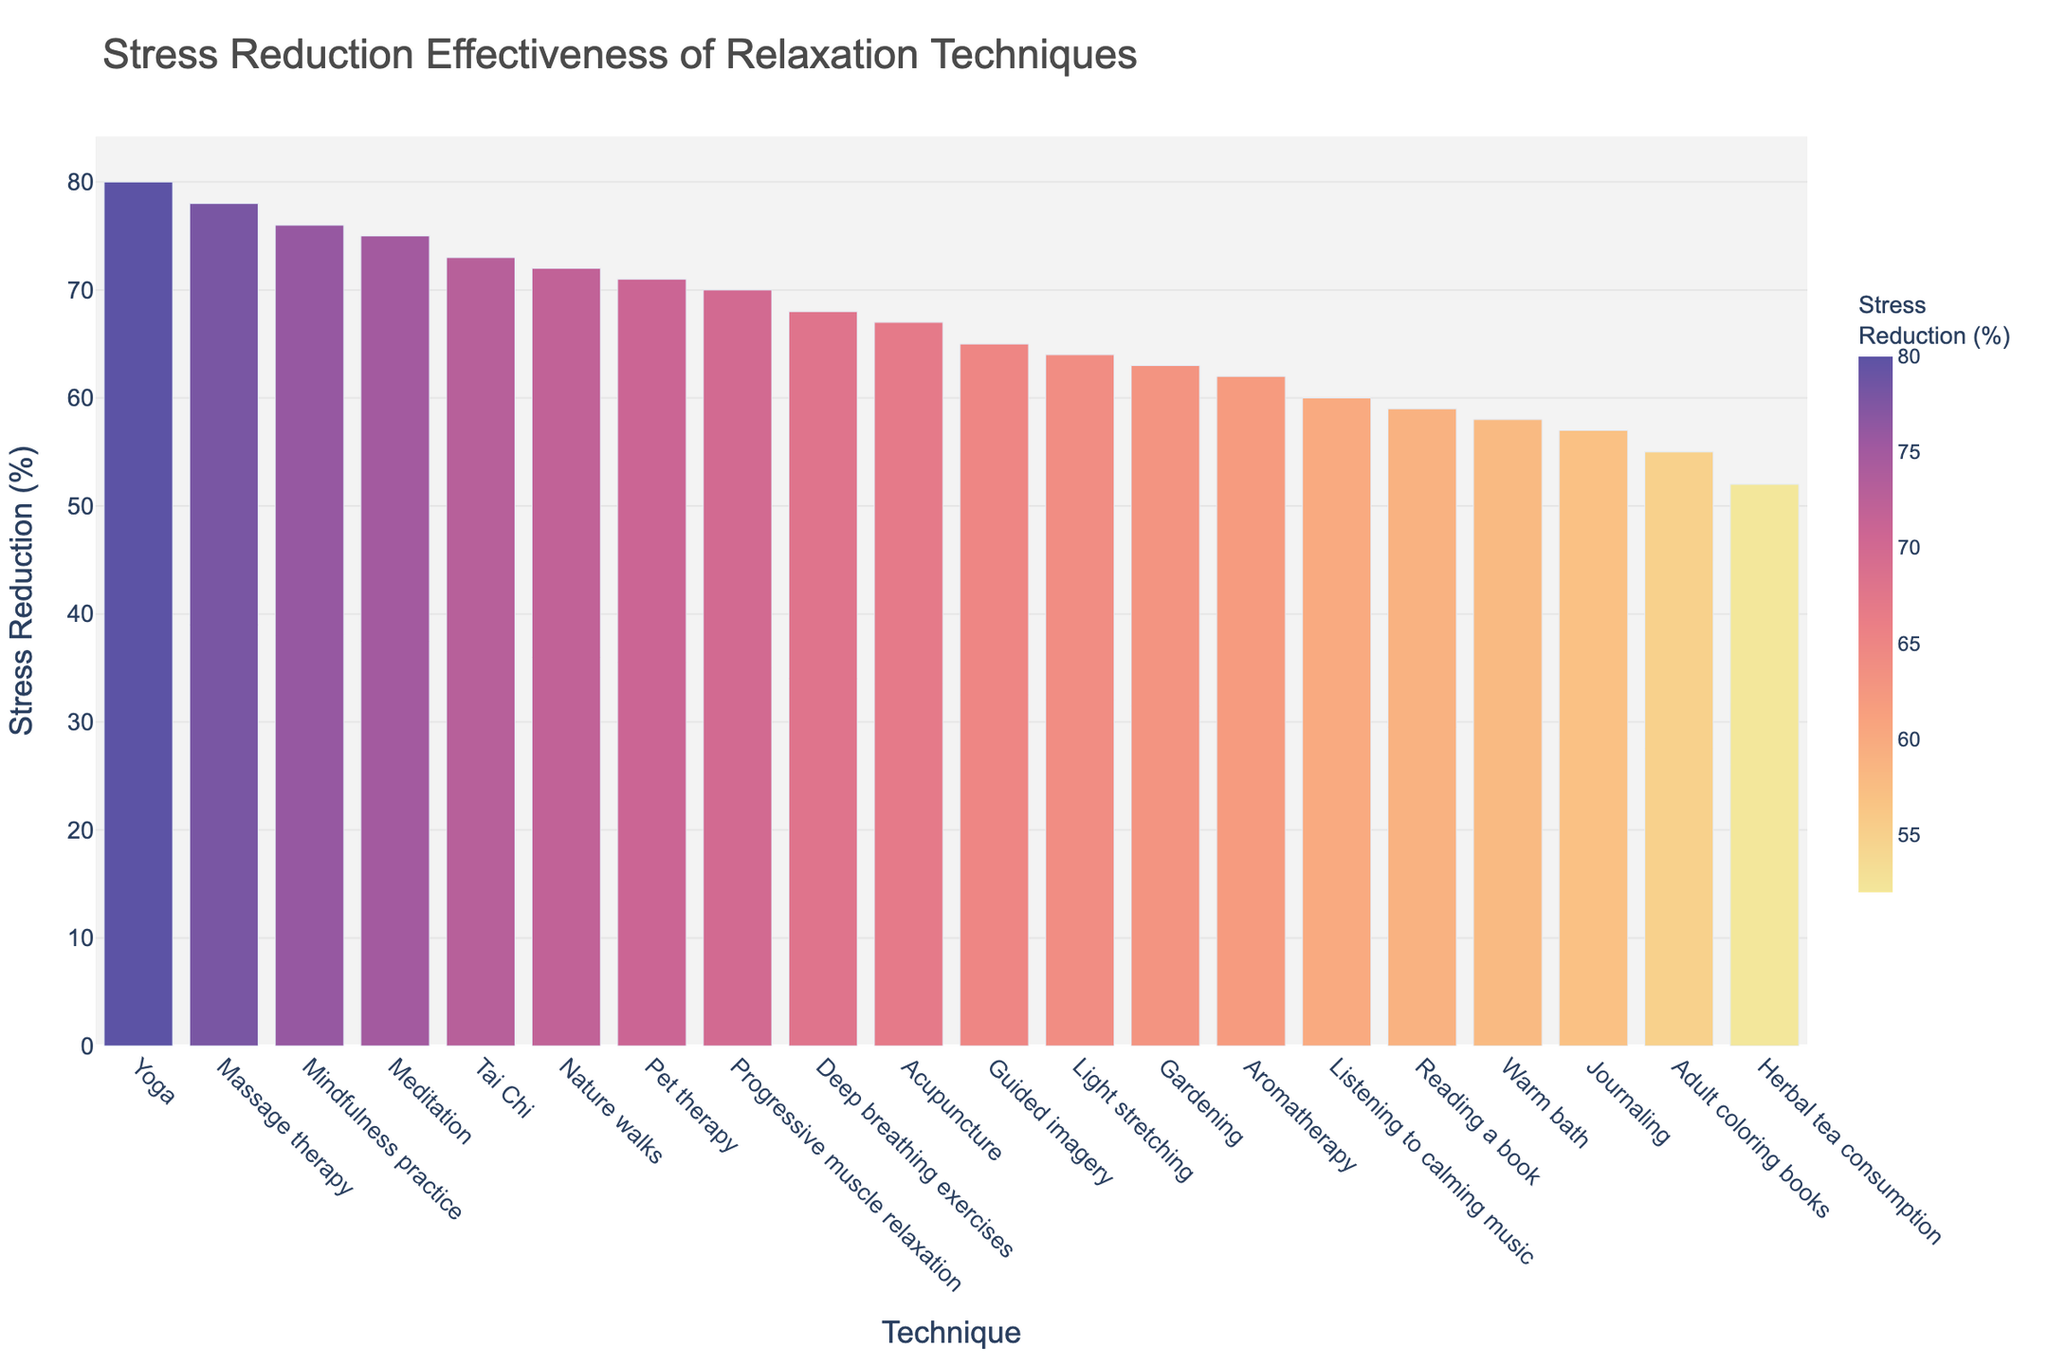Which technique has the highest stress reduction percentage? To determine which technique has the highest stress reduction percentage, we look for the bar that reaches the highest point on the y-axis, representing 80%. This bar corresponds to "Yoga".
Answer: Yoga Which technique is more effective: Deep breathing exercises or Guided imagery? Compare the bar heights for Deep breathing exercises and Guided imagery. Deep breathing exercises has a stress reduction percentage of 68%, while Guided imagery has 65%. Deep breathing exercises is more effective.
Answer: Deep breathing exercises What is the difference in stress reduction effectiveness between Massage therapy and Journaling? Find the stress reduction percentages for Massage therapy (78%) and Journaling (57%). Subtract the lower percentage from the higher one: 78% - 57% = 21%.
Answer: 21% Which technique has a stress reduction percentage closest to 70%? Look for the bars around the 70% mark on the y-axis. Progressive muscle relaxation (70%) and Pet therapy (71%) are close; Pet therapy has a percentage of 71%.
Answer: Pet therapy What are the three least effective techniques for stress reduction? Check the bars at the lowest end of the y-axis. The three lowest bars represent Herbal tea consumption (52%), Adult coloring books (55%), and Warm bath (58%).
Answer: Herbal tea consumption, Adult coloring books, Warm bath Which techniques have a stress reduction percentage above 75%? Identify the bars that extend above the 75% mark on the y-axis. The techniques are Meditation (75%), Yoga (80%), Massage therapy (78%), and Mindfulness practice (76%).
Answer: Meditation, Yoga, Massage therapy, Mindfulness practice How much more effective is Nature walks compared to Aromatherapy? Find the stress reduction percentages for Nature walks (72%) and Aromatherapy (62%). Subtract the lower percentage from the higher one: 72% - 62% = 10%.
Answer: 10% What is the median value of the stress reduction percentages? Arrange the percentages in ascending order and find the middle value. There are 20 data points, so the median is the average of the 10th (63%) and 11th (64%) values: (63% + 64%) / 2 = 63.5%.
Answer: 63.5% Which technique has a stress reduction percentage immediately higher than Guided imagery? Look for the technique with the next highest bar following Guided imagery's 65%. Light stretching has a stress reduction percentage of 64%, higher than Guided imagery but less effective than Aromatherapy (62%).
Answer: Acupuncture 